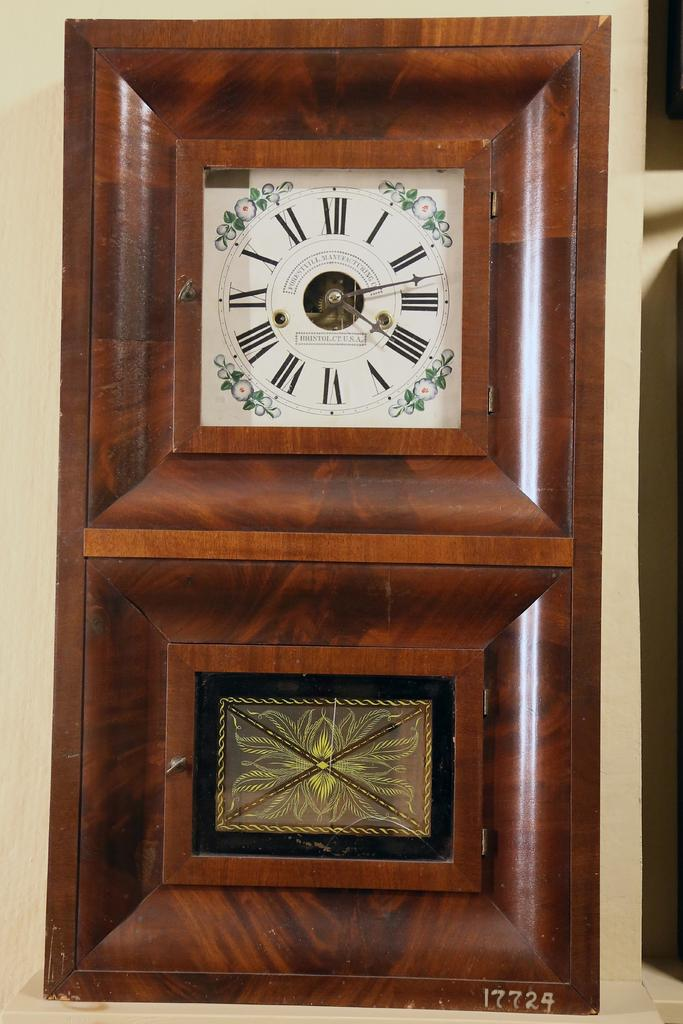<image>
Render a clear and concise summary of the photo. A grandfather clock made in Bristol, CT by the Forestville Manufacturing Co. 